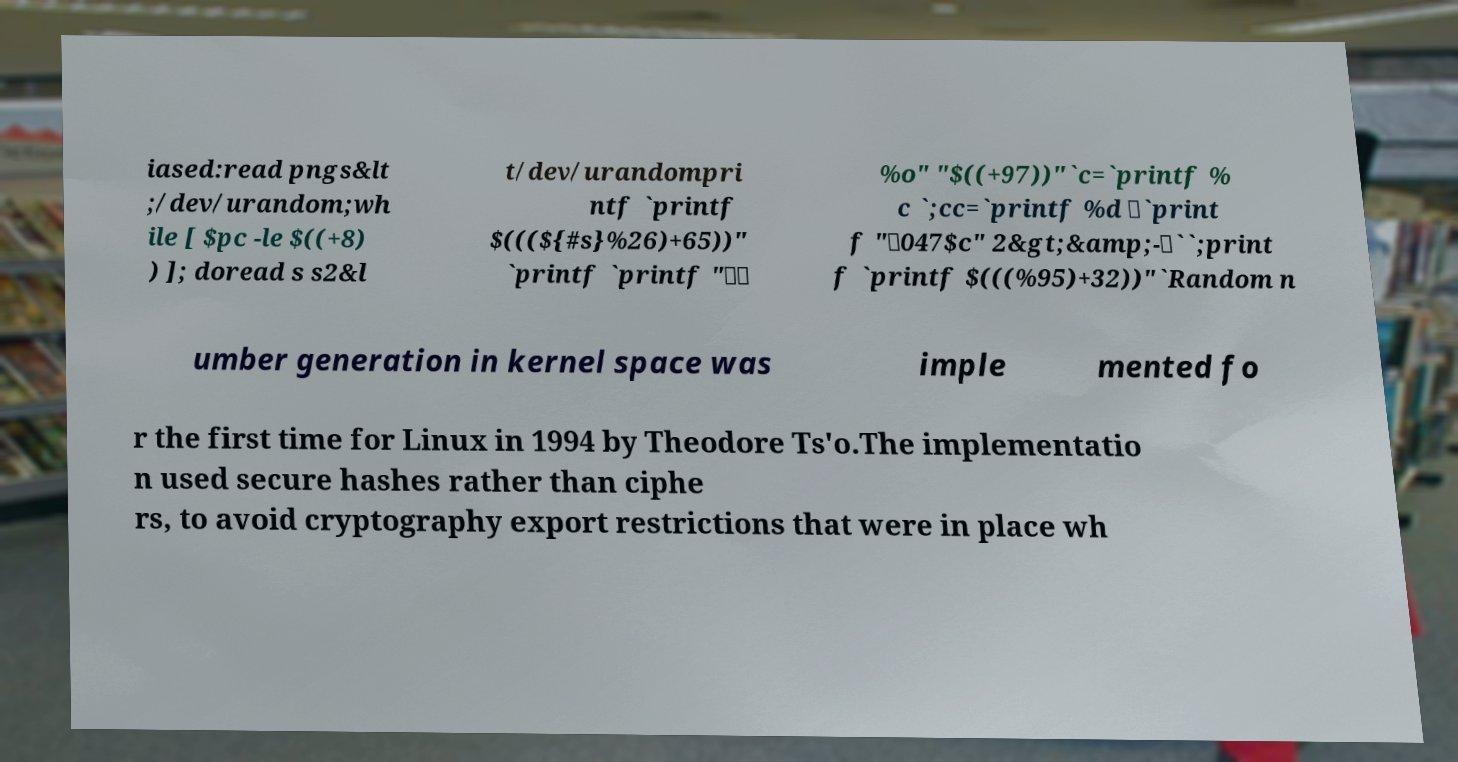Please read and relay the text visible in this image. What does it say? iased:read pngs&lt ;/dev/urandom;wh ile [ $pc -le $((+8) ) ]; doread s s2&l t/dev/urandompri ntf `printf $(((${#s}%26)+65))" `printf `printf "\\ %o" "$((+97))"`c=`printf % c `;cc=`printf %d \`print f "\047$c" 2&gt;&amp;-\``;print f `printf $(((%95)+32))"`Random n umber generation in kernel space was imple mented fo r the first time for Linux in 1994 by Theodore Ts'o.The implementatio n used secure hashes rather than ciphe rs, to avoid cryptography export restrictions that were in place wh 